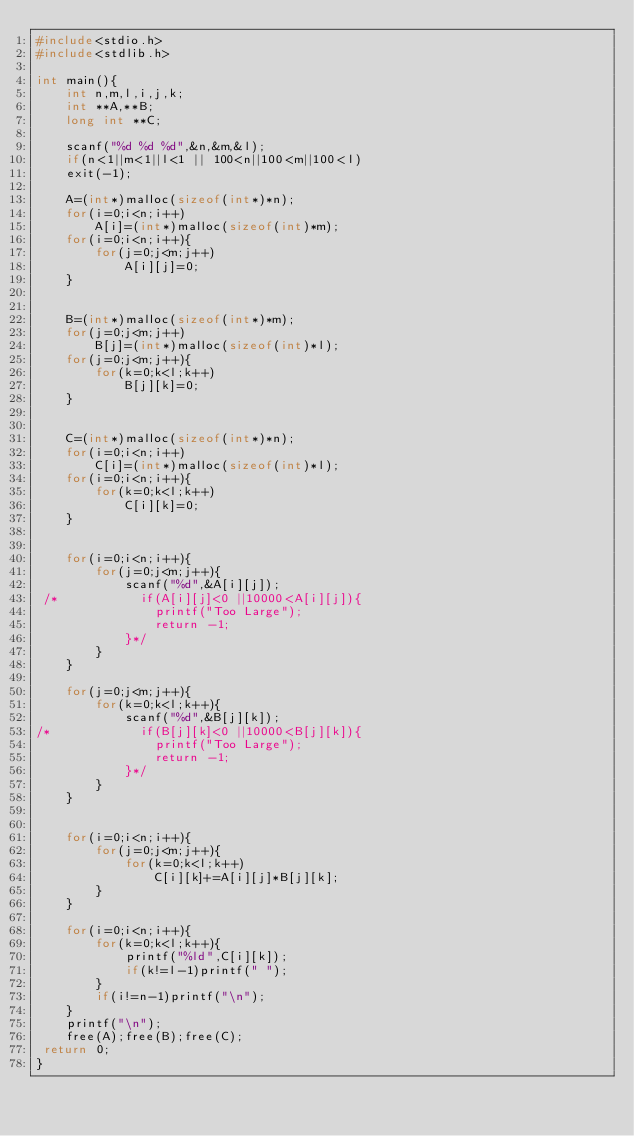Convert code to text. <code><loc_0><loc_0><loc_500><loc_500><_C_>#include<stdio.h>
#include<stdlib.h>

int main(){
    int n,m,l,i,j,k;
    int **A,**B;
    long int **C;

    scanf("%d %d %d",&n,&m,&l);
    if(n<1||m<1||l<1 || 100<n||100<m||100<l)
    exit(-1);

    A=(int*)malloc(sizeof(int*)*n);
    for(i=0;i<n;i++)
        A[i]=(int*)malloc(sizeof(int)*m);
    for(i=0;i<n;i++){
        for(j=0;j<m;j++)
            A[i][j]=0;
    }


    B=(int*)malloc(sizeof(int*)*m);
    for(j=0;j<m;j++)
        B[j]=(int*)malloc(sizeof(int)*l);
    for(j=0;j<m;j++){
        for(k=0;k<l;k++)
            B[j][k]=0;
    }


    C=(int*)malloc(sizeof(int*)*n);
    for(i=0;i<n;i++)
        C[i]=(int*)malloc(sizeof(int)*l);
    for(i=0;i<n;i++){
        for(k=0;k<l;k++)
            C[i][k]=0;
    }


    for(i=0;i<n;i++){
        for(j=0;j<m;j++){
            scanf("%d",&A[i][j]);
 /*           if(A[i][j]<0 ||10000<A[i][j]){
                printf("Too Large");
                return -1;
            }*/
        }
    }

    for(j=0;j<m;j++){
        for(k=0;k<l;k++){
            scanf("%d",&B[j][k]);
/*            if(B[j][k]<0 ||10000<B[j][k]){
                printf("Too Large");
                return -1;
            }*/
        }
    }


    for(i=0;i<n;i++){
        for(j=0;j<m;j++){
            for(k=0;k<l;k++)
                C[i][k]+=A[i][j]*B[j][k];
        }
    }

    for(i=0;i<n;i++){
        for(k=0;k<l;k++){
            printf("%ld",C[i][k]);
            if(k!=l-1)printf(" ");
        }
        if(i!=n-1)printf("\n");
    }
    printf("\n");
    free(A);free(B);free(C);
 return 0;
}</code> 